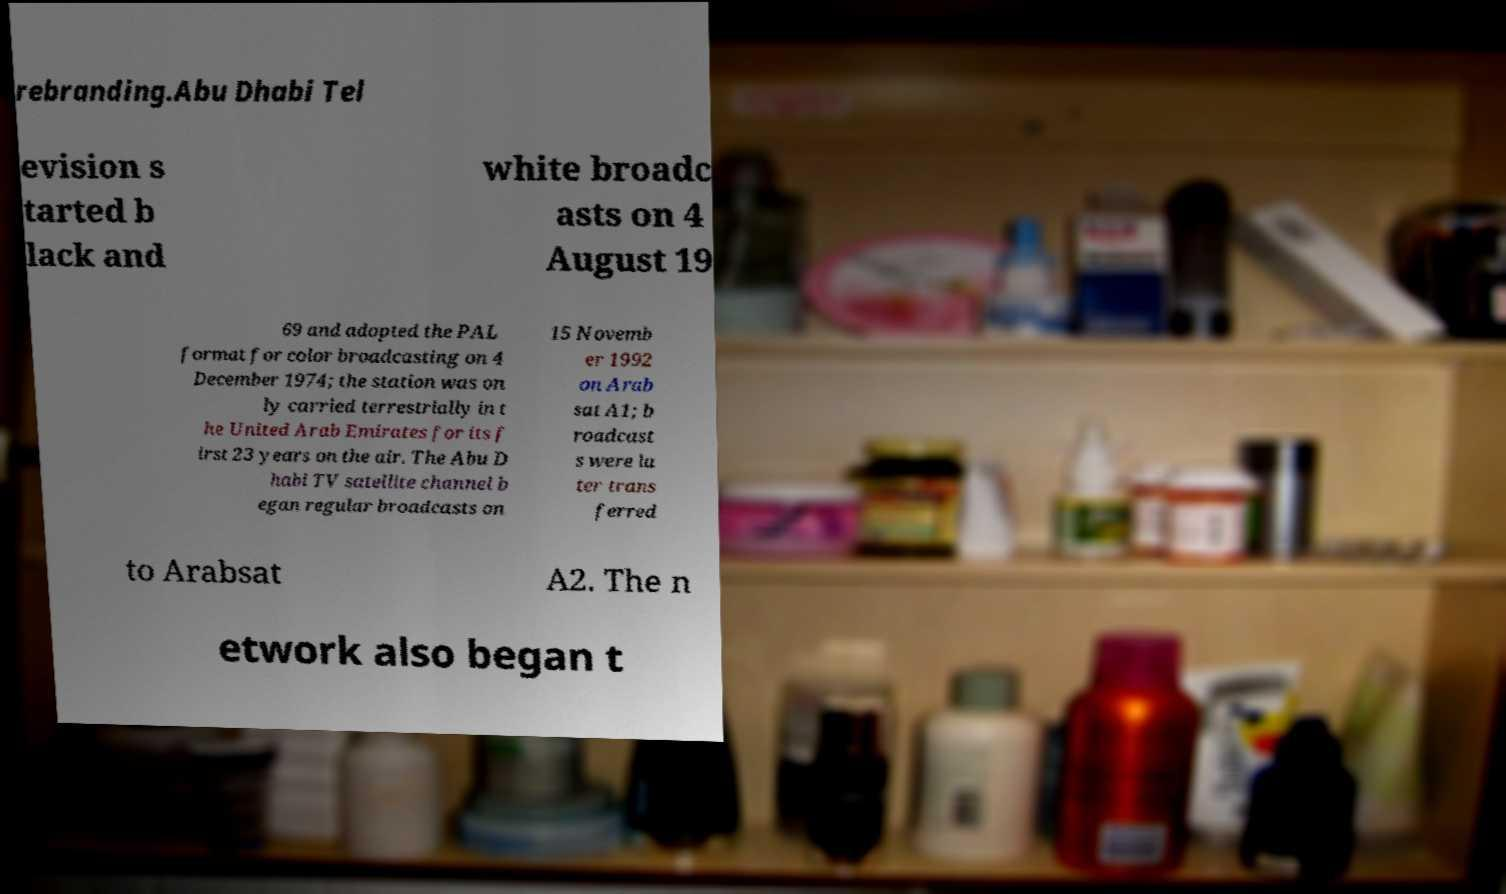There's text embedded in this image that I need extracted. Can you transcribe it verbatim? rebranding.Abu Dhabi Tel evision s tarted b lack and white broadc asts on 4 August 19 69 and adopted the PAL format for color broadcasting on 4 December 1974; the station was on ly carried terrestrially in t he United Arab Emirates for its f irst 23 years on the air. The Abu D habi TV satellite channel b egan regular broadcasts on 15 Novemb er 1992 on Arab sat A1; b roadcast s were la ter trans ferred to Arabsat A2. The n etwork also began t 